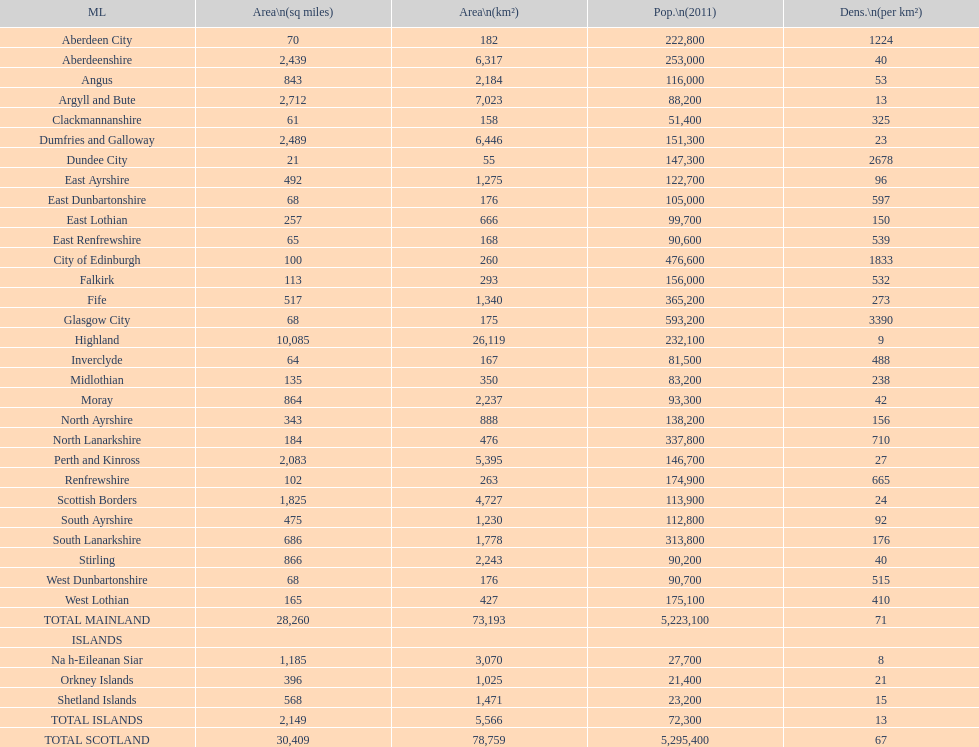What is the average population density in mainland cities? 71. 